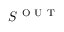<formula> <loc_0><loc_0><loc_500><loc_500>S ^ { O U T }</formula> 